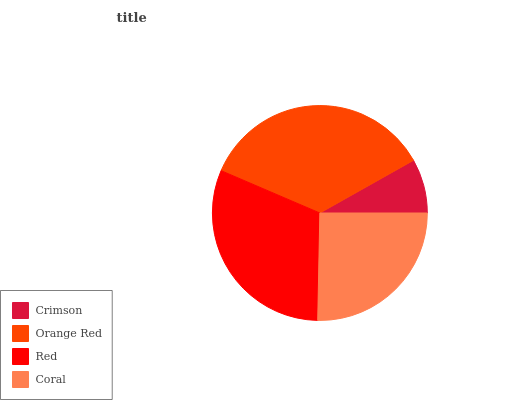Is Crimson the minimum?
Answer yes or no. Yes. Is Orange Red the maximum?
Answer yes or no. Yes. Is Red the minimum?
Answer yes or no. No. Is Red the maximum?
Answer yes or no. No. Is Orange Red greater than Red?
Answer yes or no. Yes. Is Red less than Orange Red?
Answer yes or no. Yes. Is Red greater than Orange Red?
Answer yes or no. No. Is Orange Red less than Red?
Answer yes or no. No. Is Red the high median?
Answer yes or no. Yes. Is Coral the low median?
Answer yes or no. Yes. Is Orange Red the high median?
Answer yes or no. No. Is Crimson the low median?
Answer yes or no. No. 